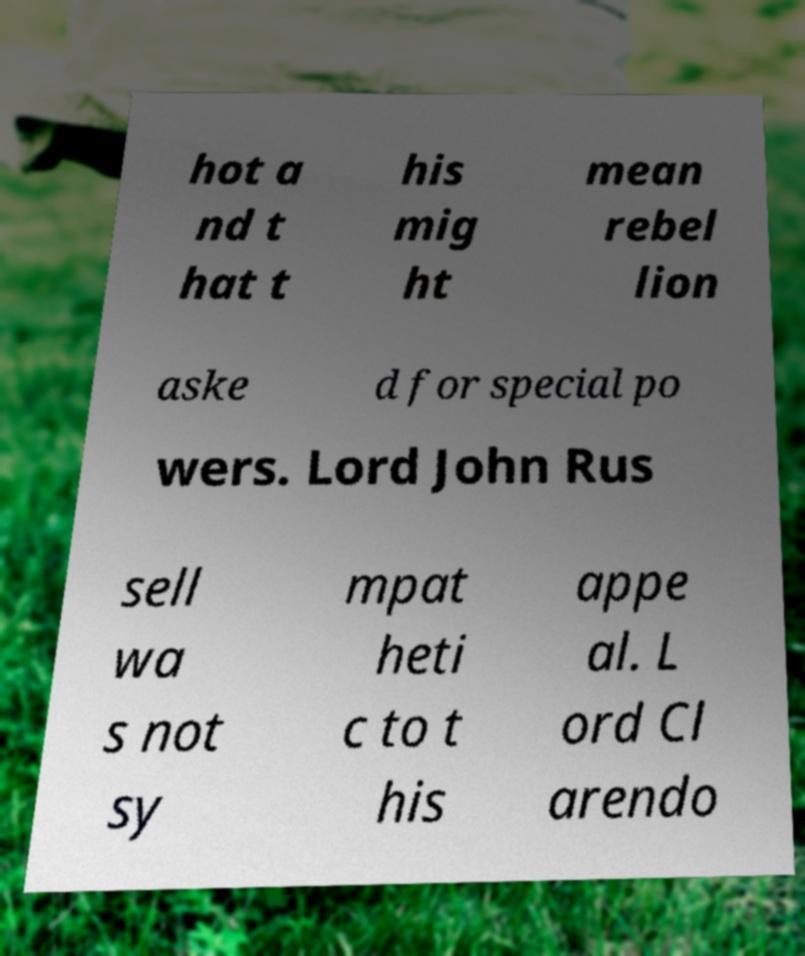Could you extract and type out the text from this image? hot a nd t hat t his mig ht mean rebel lion aske d for special po wers. Lord John Rus sell wa s not sy mpat heti c to t his appe al. L ord Cl arendo 